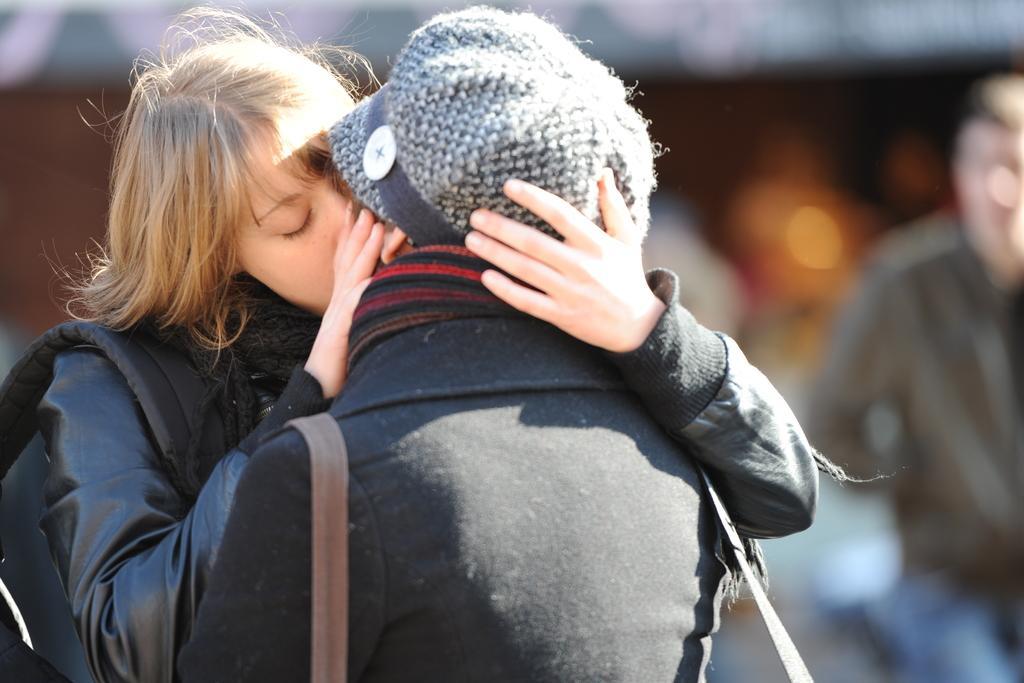In one or two sentences, can you explain what this image depicts? In the image there are two people kissing each other and background of the people is blur. 